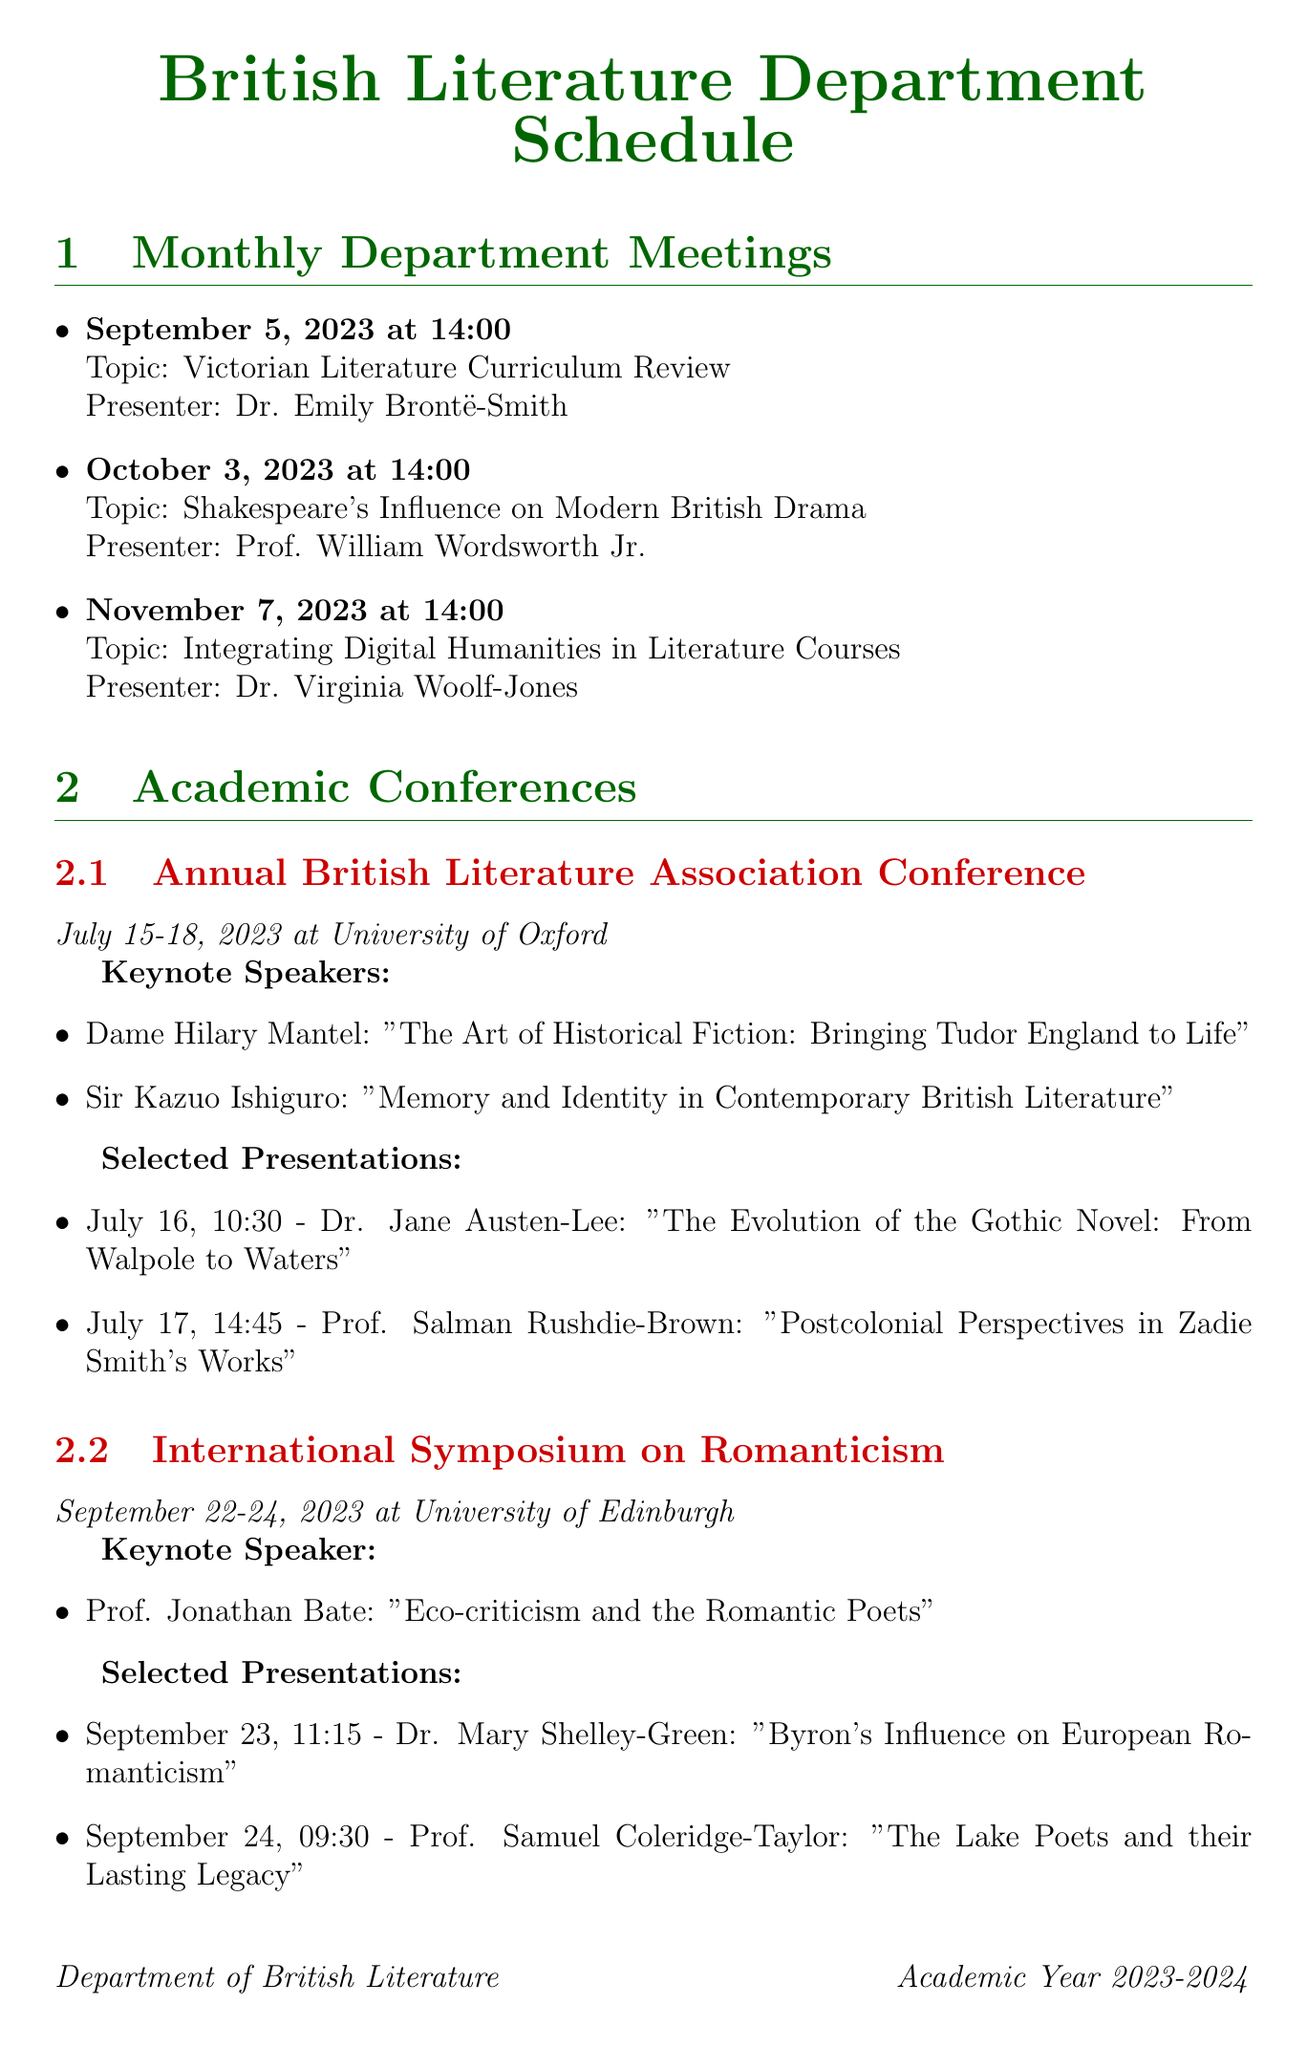What is the date of the first department meeting? The first department meeting is scheduled for September 5, 2023.
Answer: September 5, 2023 Who is presenting on integrating digital humanities? The presenter for this topic is Dr. Virginia Woolf-Jones at the November meeting.
Answer: Dr. Virginia Woolf-Jones What is the topic of the presentation by Dr. Mary Shelley-Green? Dr. Mary Shelley-Green's presentation focuses on Byron's influence in European Romanticism.
Answer: Byron's Influence on European Romanticism How many keynote speakers are listed for the Annual British Literature Association Conference? There are two keynote speakers mentioned for this conference.
Answer: Two Which location hosted the International Symposium on Romanticism? The document states that the symposium took place at the University of Edinburgh.
Answer: University of Edinburgh What time does the presentation on postcolonial perspectives occur? The presentation by Prof. Salman Rushdie-Brown is scheduled for 14:45 on July 17.
Answer: 14:45 What is the title of the keynote address by Dame Hilary Mantel? The title of Dame Hilary Mantel's keynote address discusses historical fiction relating to Tudor England.
Answer: The Art of Historical Fiction: Bringing Tudor England to Life What is the last department meeting listed in the schedule? The final department meeting mentioned is on November 7, 2023.
Answer: November 7, 2023 